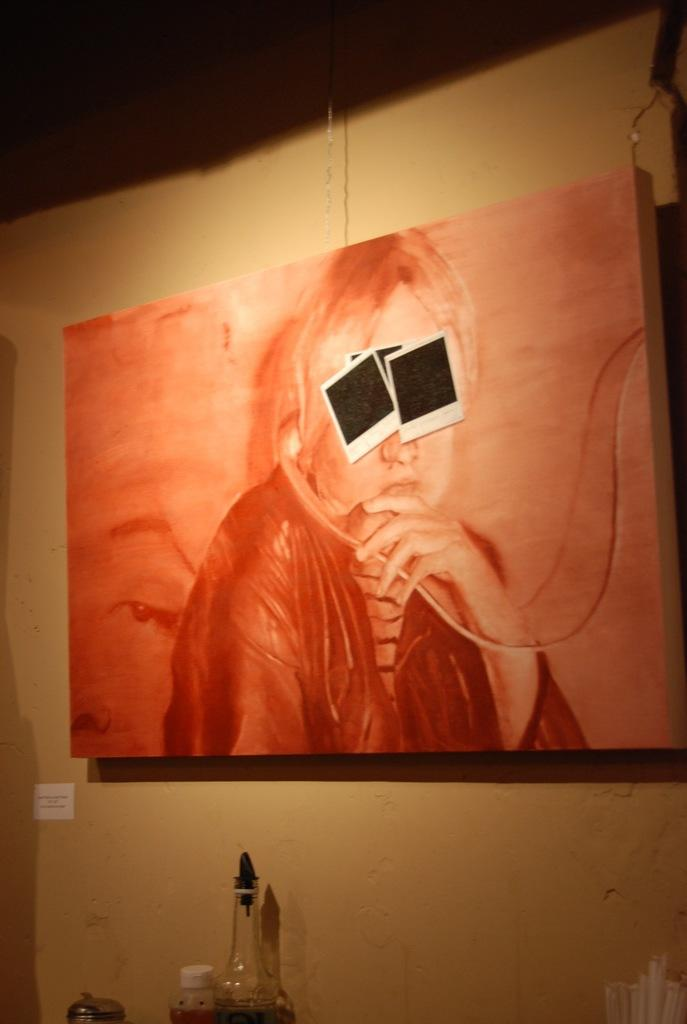What is displayed on the wall in the image? There is a painting on a wall in the image. Are there any additional items attached to the painting? Yes, there are photographs attached to the painting. What objects can be seen at the bottom of the wall? There is a bottle and a plastic jar at the bottom of the wall. How many birds are sitting on the rod in the image? There is no rod or birds present in the image. Are there any chickens visible in the image? There are no chickens present in the image. 